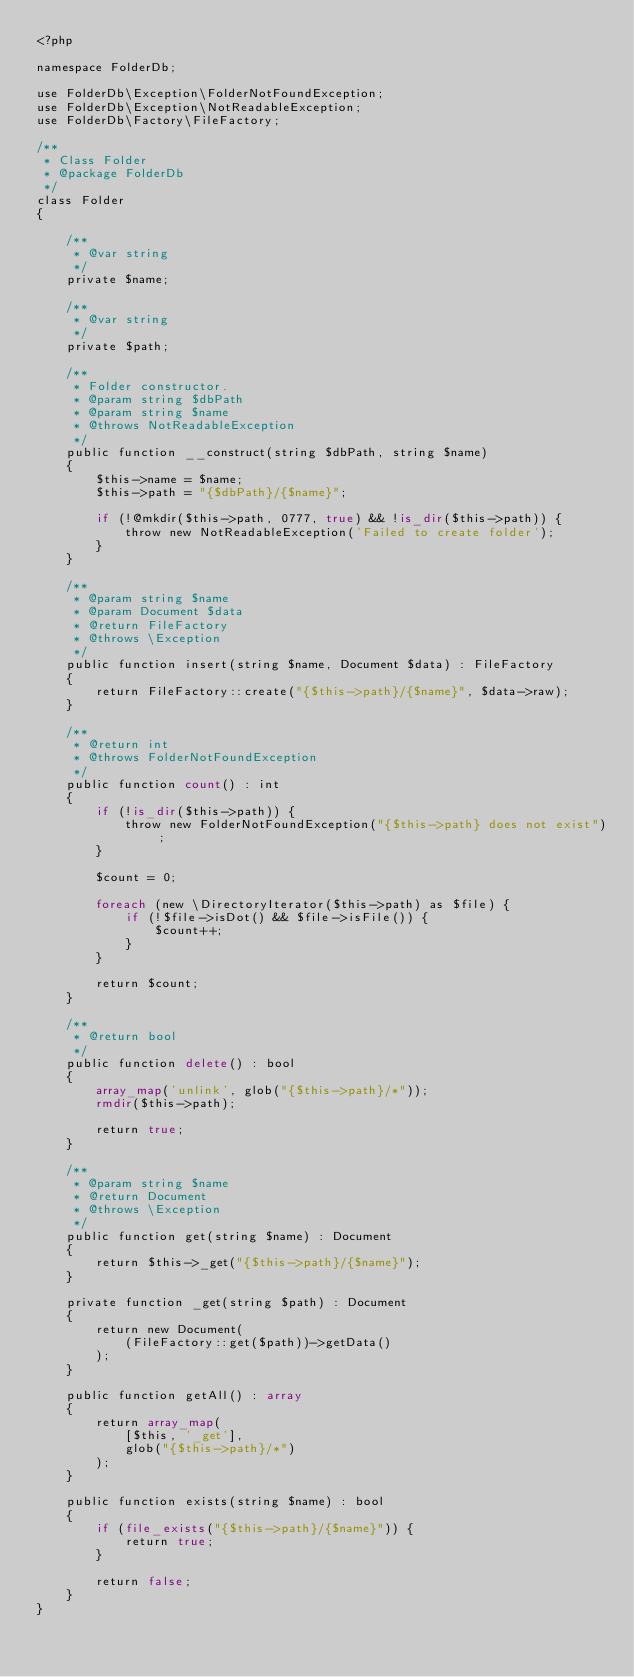Convert code to text. <code><loc_0><loc_0><loc_500><loc_500><_PHP_><?php

namespace FolderDb;

use FolderDb\Exception\FolderNotFoundException;
use FolderDb\Exception\NotReadableException;
use FolderDb\Factory\FileFactory;

/**
 * Class Folder
 * @package FolderDb
 */
class Folder
{

    /**
     * @var string
     */
    private $name;

    /**
     * @var string
     */
    private $path;

    /**
     * Folder constructor.
     * @param string $dbPath
     * @param string $name
     * @throws NotReadableException
     */
    public function __construct(string $dbPath, string $name)
    {
        $this->name = $name;
        $this->path = "{$dbPath}/{$name}";

        if (!@mkdir($this->path, 0777, true) && !is_dir($this->path)) {
            throw new NotReadableException('Failed to create folder');
        }
    }

    /**
     * @param string $name
     * @param Document $data
     * @return FileFactory
     * @throws \Exception
     */
    public function insert(string $name, Document $data) : FileFactory
    {
        return FileFactory::create("{$this->path}/{$name}", $data->raw);
    }

    /**
     * @return int
     * @throws FolderNotFoundException
     */
    public function count() : int
    {
        if (!is_dir($this->path)) {
            throw new FolderNotFoundException("{$this->path} does not exist");
        }

        $count = 0;

        foreach (new \DirectoryIterator($this->path) as $file) {
            if (!$file->isDot() && $file->isFile()) {
                $count++;
            }
        }

        return $count;
    }

    /**
     * @return bool
     */
    public function delete() : bool
    {
        array_map('unlink', glob("{$this->path}/*"));
        rmdir($this->path);

        return true;
    }

    /**
     * @param string $name
     * @return Document
     * @throws \Exception
     */
    public function get(string $name) : Document
    {
        return $this->_get("{$this->path}/{$name}");
    }

    private function _get(string $path) : Document
    {
        return new Document(
            (FileFactory::get($path))->getData()
        );
    }

    public function getAll() : array
    {
        return array_map(
            [$this, '_get'],
            glob("{$this->path}/*")
        );
    }

    public function exists(string $name) : bool
    {
        if (file_exists("{$this->path}/{$name}")) {
            return true;
        }

        return false;
    }
}</code> 